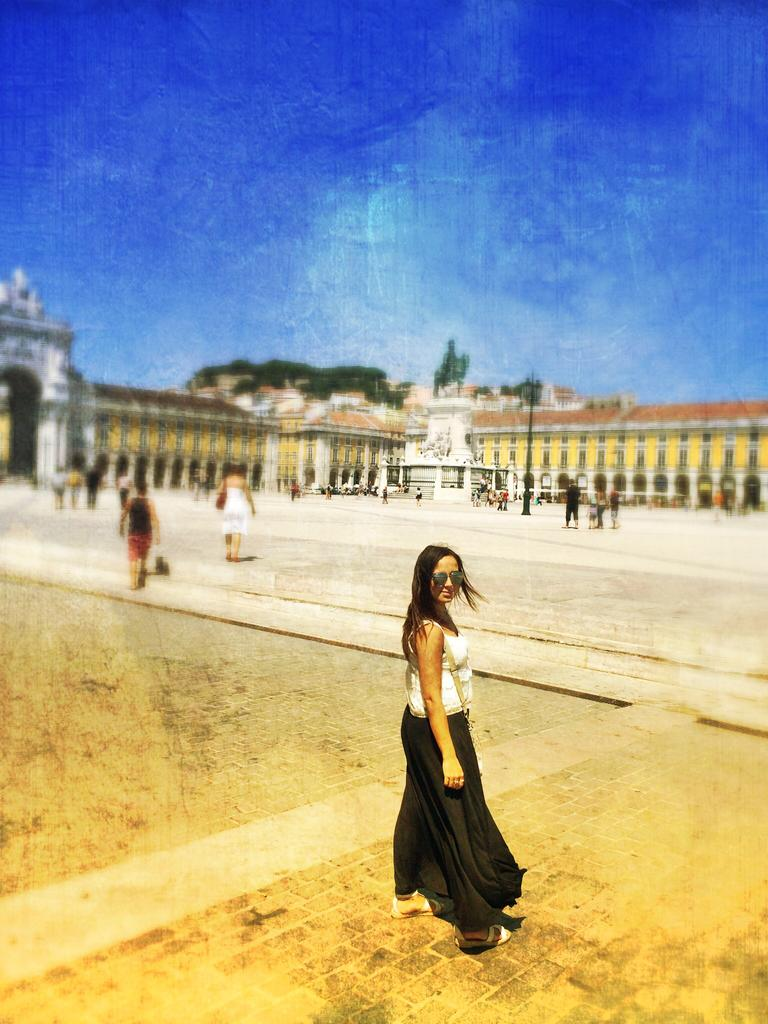What type of structure is in the image? There is a fort in the image. What can be seen in the background of the image? The sky is visible in the background of the image. What are the people in the image doing? There are people walking in front of the fort. Who is in the foreground of the image? A woman is standing in the foreground of the image. What type of good-bye is the woman saying to the people walking in the image? There is no indication in the image that the woman is saying good-bye to anyone. 